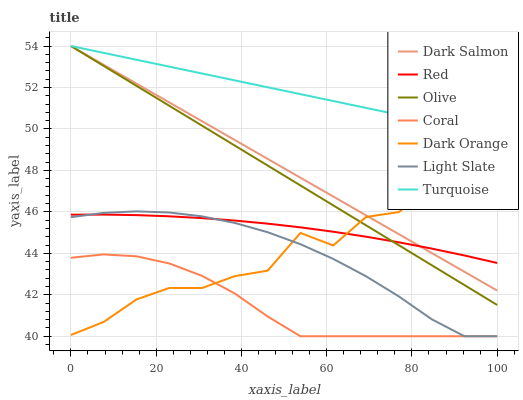Does Coral have the minimum area under the curve?
Answer yes or no. Yes. Does Turquoise have the maximum area under the curve?
Answer yes or no. Yes. Does Light Slate have the minimum area under the curve?
Answer yes or no. No. Does Light Slate have the maximum area under the curve?
Answer yes or no. No. Is Dark Salmon the smoothest?
Answer yes or no. Yes. Is Dark Orange the roughest?
Answer yes or no. Yes. Is Turquoise the smoothest?
Answer yes or no. No. Is Turquoise the roughest?
Answer yes or no. No. Does Turquoise have the lowest value?
Answer yes or no. No. Does Olive have the highest value?
Answer yes or no. Yes. Does Light Slate have the highest value?
Answer yes or no. No. Is Light Slate less than Olive?
Answer yes or no. Yes. Is Olive greater than Light Slate?
Answer yes or no. Yes. Does Red intersect Dark Salmon?
Answer yes or no. Yes. Is Red less than Dark Salmon?
Answer yes or no. No. Is Red greater than Dark Salmon?
Answer yes or no. No. Does Light Slate intersect Olive?
Answer yes or no. No. 